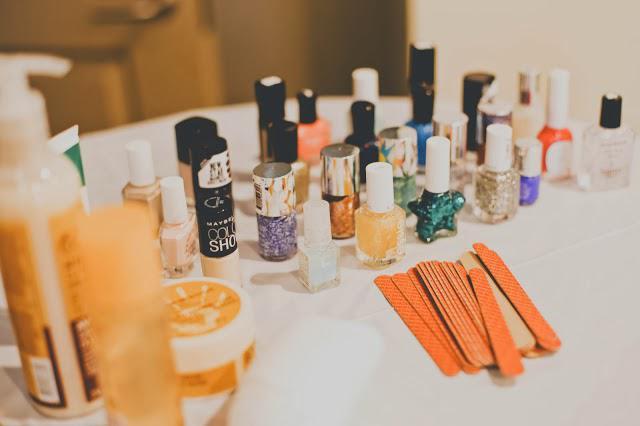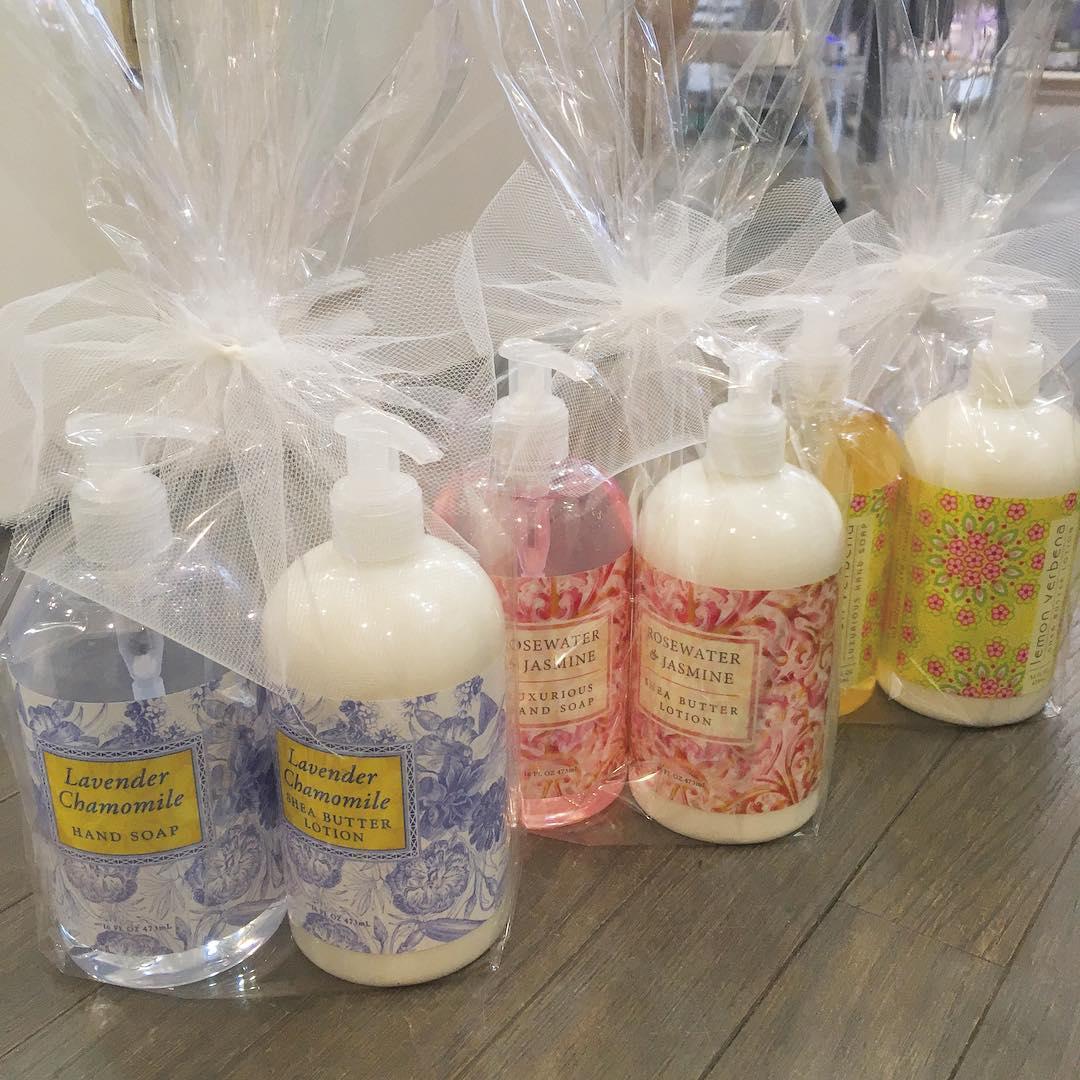The first image is the image on the left, the second image is the image on the right. Assess this claim about the two images: "At least one image has exactly three containers.". Correct or not? Answer yes or no. No. 